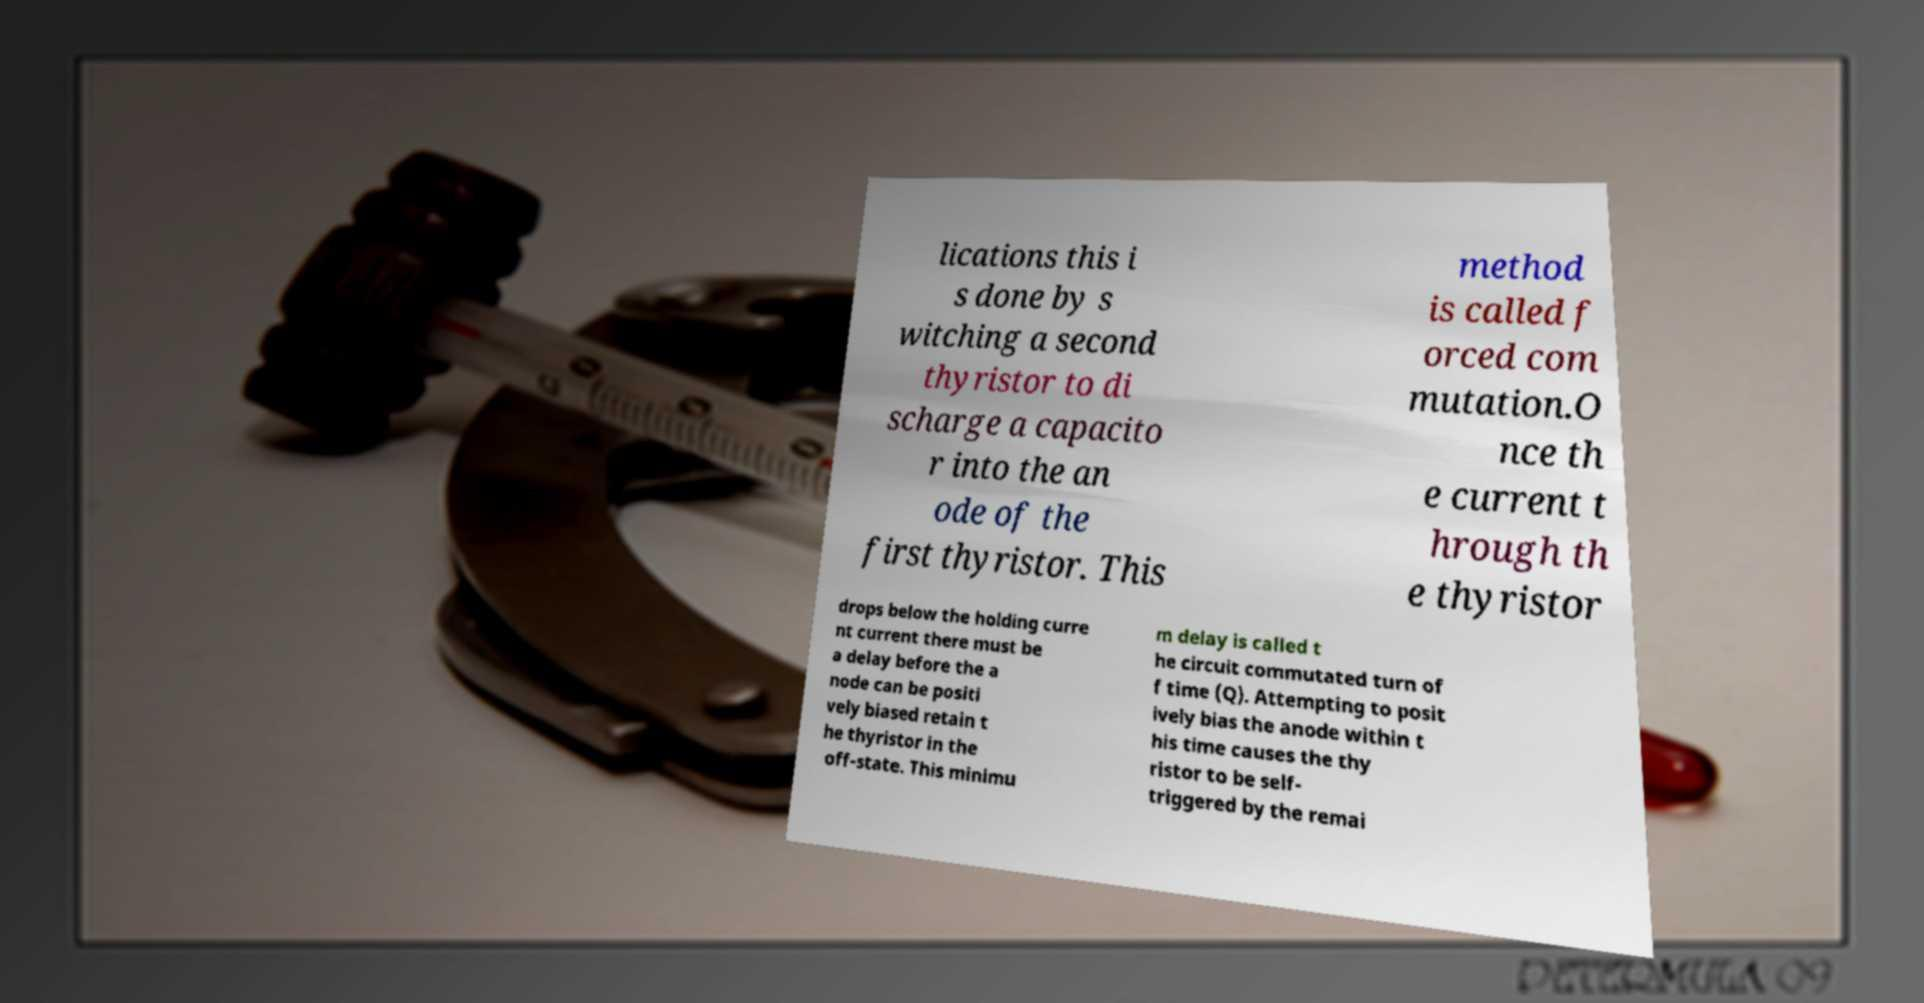Could you assist in decoding the text presented in this image and type it out clearly? lications this i s done by s witching a second thyristor to di scharge a capacito r into the an ode of the first thyristor. This method is called f orced com mutation.O nce th e current t hrough th e thyristor drops below the holding curre nt current there must be a delay before the a node can be positi vely biased retain t he thyristor in the off-state. This minimu m delay is called t he circuit commutated turn of f time (Q). Attempting to posit ively bias the anode within t his time causes the thy ristor to be self- triggered by the remai 